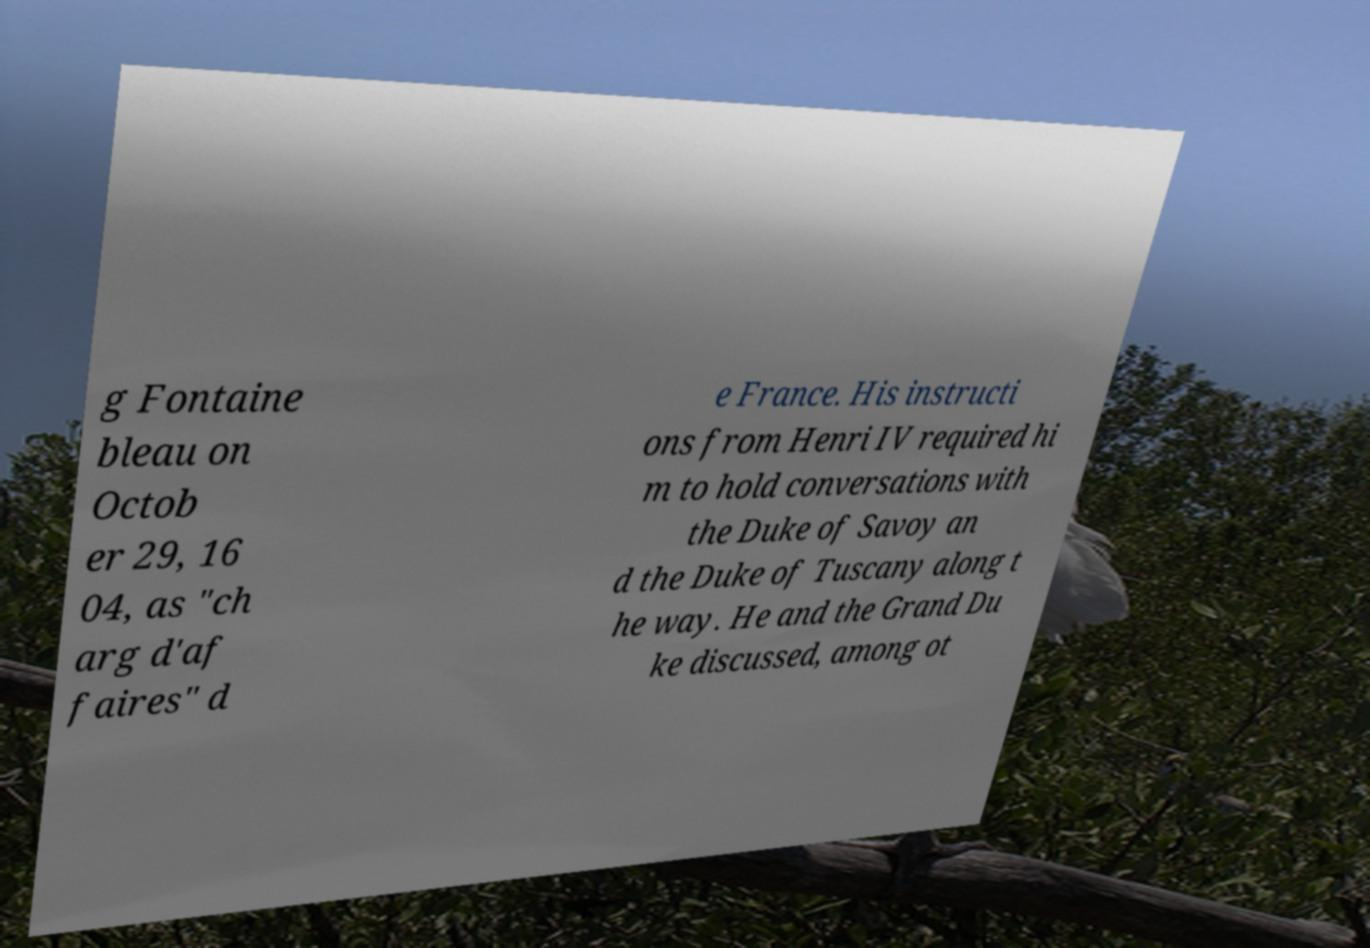There's text embedded in this image that I need extracted. Can you transcribe it verbatim? g Fontaine bleau on Octob er 29, 16 04, as "ch arg d'af faires" d e France. His instructi ons from Henri IV required hi m to hold conversations with the Duke of Savoy an d the Duke of Tuscany along t he way. He and the Grand Du ke discussed, among ot 